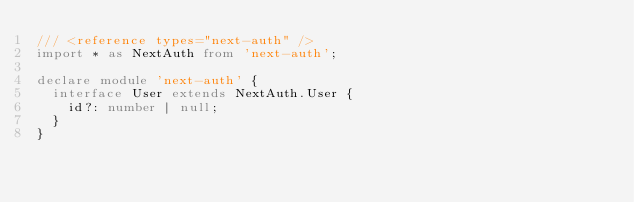Convert code to text. <code><loc_0><loc_0><loc_500><loc_500><_TypeScript_>/// <reference types="next-auth" />
import * as NextAuth from 'next-auth';

declare module 'next-auth' {
  interface User extends NextAuth.User {
    id?: number | null;
  }
}
</code> 